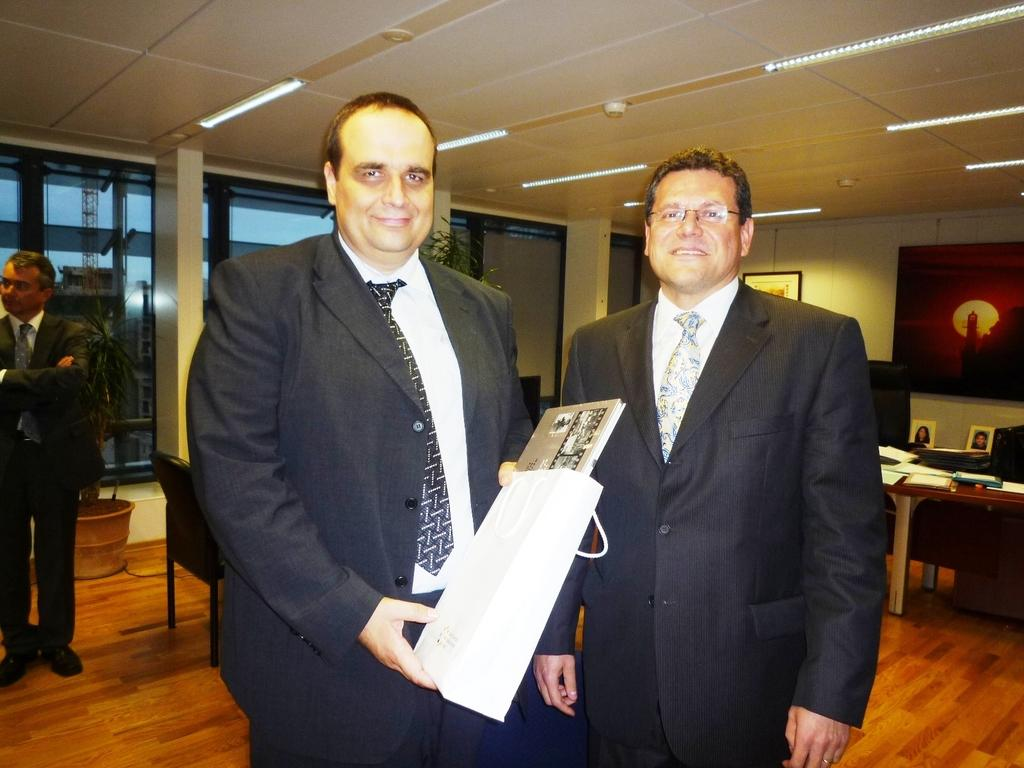How many people are in the image? There are 2 men in the image. What is one of the men holding? A person is holding a cover. What can be seen through the windows in the image? The windows in the image provide a view of the surroundings. What type of decoration is on the wall? There are frames on the wall. What piece of furniture is present in the image? There is a table in the image. What type of seating is available in the image? There are chairs in the image. What type of plant is present in the image? A house plant is present in the image. What type of crime is being committed in the image? There is no indication of any crime being committed in the image. How many pears are visible on the table in the image? There are no pears present in the image. How many chickens are visible in the image? There are no chickens present in the image. 